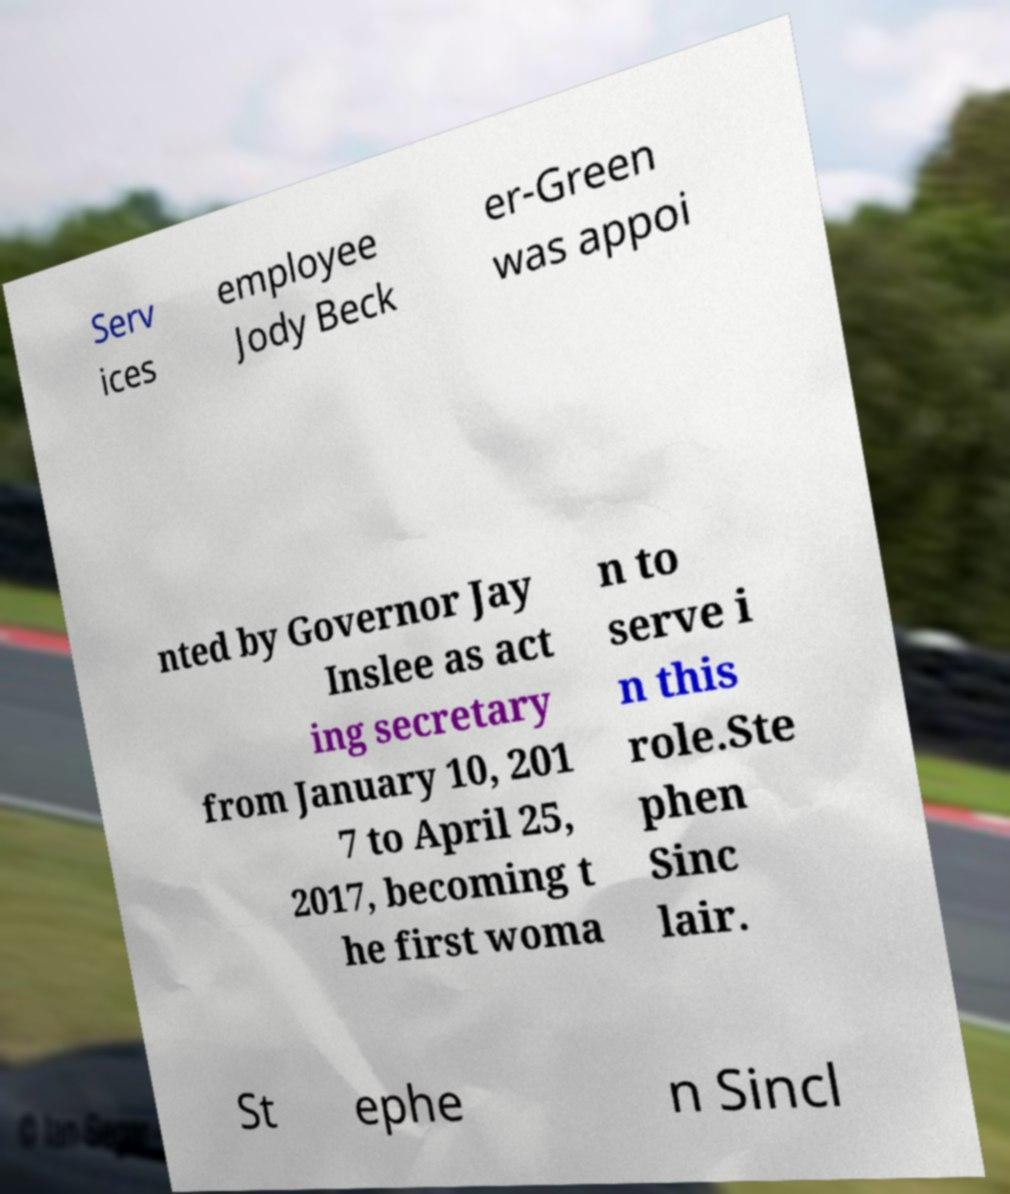What messages or text are displayed in this image? I need them in a readable, typed format. Serv ices employee Jody Beck er-Green was appoi nted by Governor Jay Inslee as act ing secretary from January 10, 201 7 to April 25, 2017, becoming t he first woma n to serve i n this role.Ste phen Sinc lair. St ephe n Sincl 